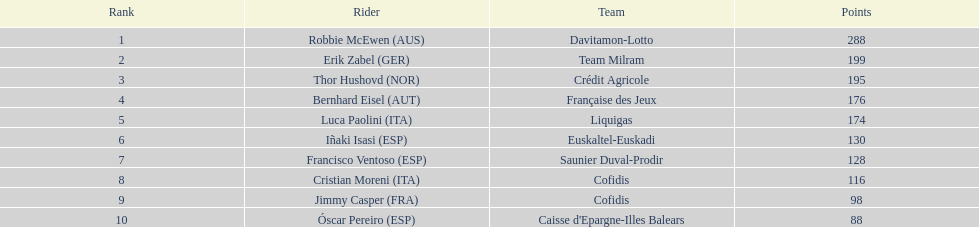By how many points did erik zabel surpass francisco ventoso? 71. 